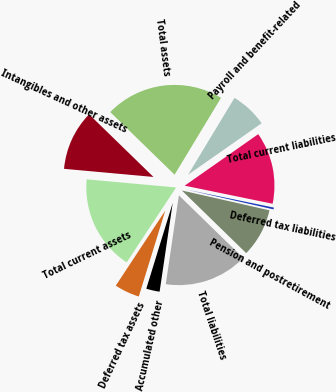Convert chart. <chart><loc_0><loc_0><loc_500><loc_500><pie_chart><fcel>Deferred tax assets<fcel>Total current assets<fcel>Intangibles and other assets<fcel>Total assets<fcel>Payroll and benefit-related<fcel>Total current liabilities<fcel>Deferred tax liabilities<fcel>Pension and postretirement<fcel>Total liabilities<fcel>Accumulated other<nl><fcel>4.53%<fcel>17.16%<fcel>10.84%<fcel>21.37%<fcel>6.63%<fcel>12.95%<fcel>0.32%<fcel>8.74%<fcel>15.05%<fcel>2.42%<nl></chart> 